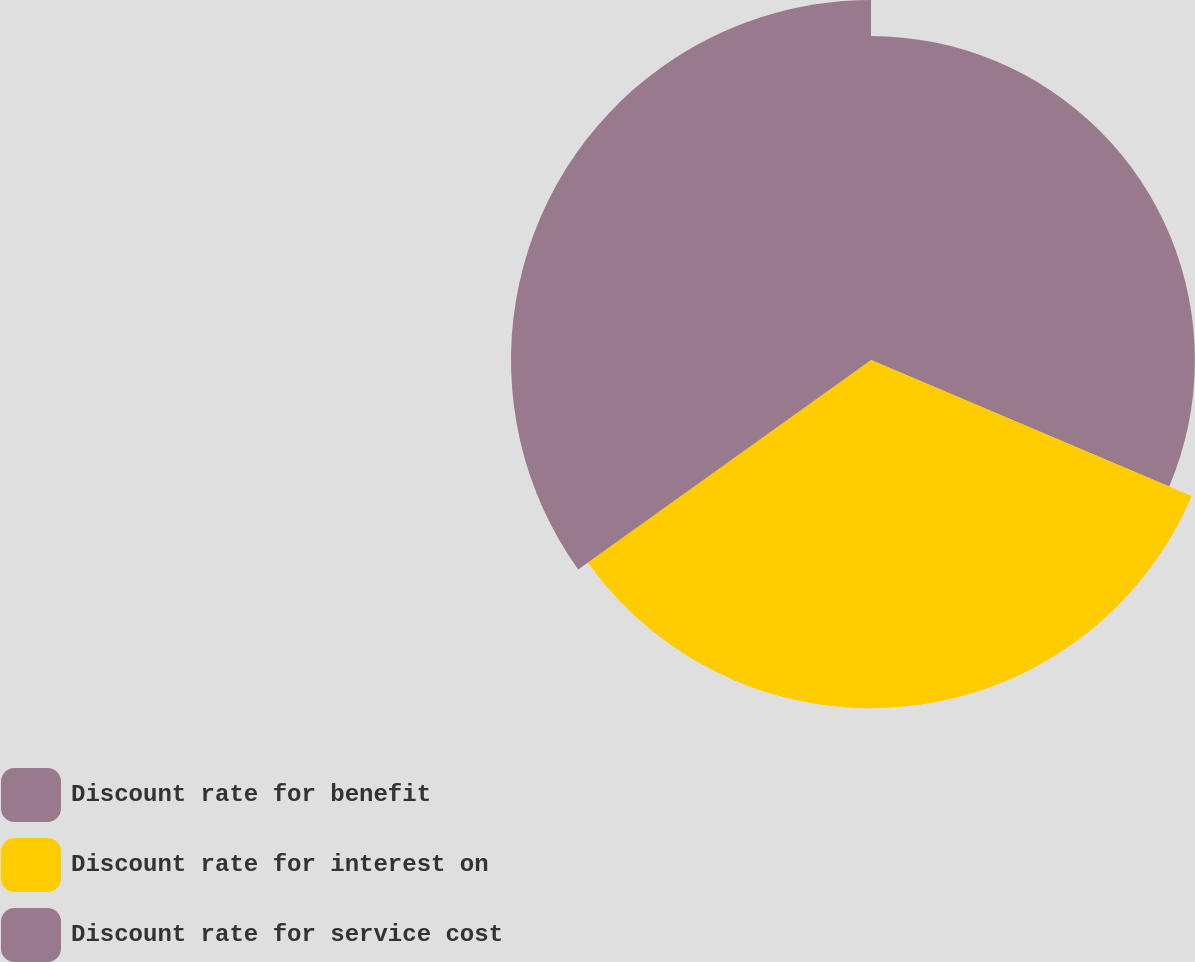Convert chart to OTSL. <chart><loc_0><loc_0><loc_500><loc_500><pie_chart><fcel>Discount rate for benefit<fcel>Discount rate for interest on<fcel>Discount rate for service cost<nl><fcel>31.38%<fcel>33.74%<fcel>34.88%<nl></chart> 